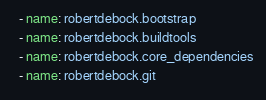<code> <loc_0><loc_0><loc_500><loc_500><_YAML_>  - name: robertdebock.bootstrap
  - name: robertdebock.buildtools
  - name: robertdebock.core_dependencies
  - name: robertdebock.git
</code> 